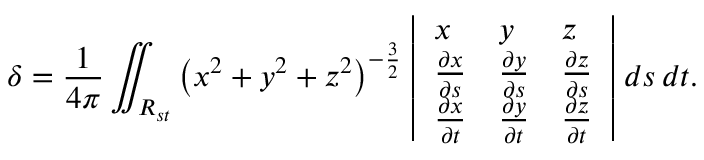<formula> <loc_0><loc_0><loc_500><loc_500>\delta = { \frac { 1 } { 4 \pi } } \iint _ { R _ { s t } } \left ( x ^ { 2 } + y ^ { 2 } + z ^ { 2 } \right ) ^ { - { \frac { 3 } { 2 } } } { \left | \begin{array} { l l l } { x } & { y } & { z } \\ { { \frac { \partial x } { \partial s } } } & { { \frac { \partial y } { \partial s } } } & { { \frac { \partial z } { \partial s } } } \\ { { \frac { \partial x } { \partial t } } } & { { \frac { \partial y } { \partial t } } } & { { \frac { \partial z } { \partial t } } } \end{array} \right | } \, d s \, d t .</formula> 